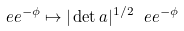Convert formula to latex. <formula><loc_0><loc_0><loc_500><loc_500>\ e e ^ { - \phi } \mapsto | \det a | ^ { 1 / 2 } \ e e ^ { - \phi }</formula> 